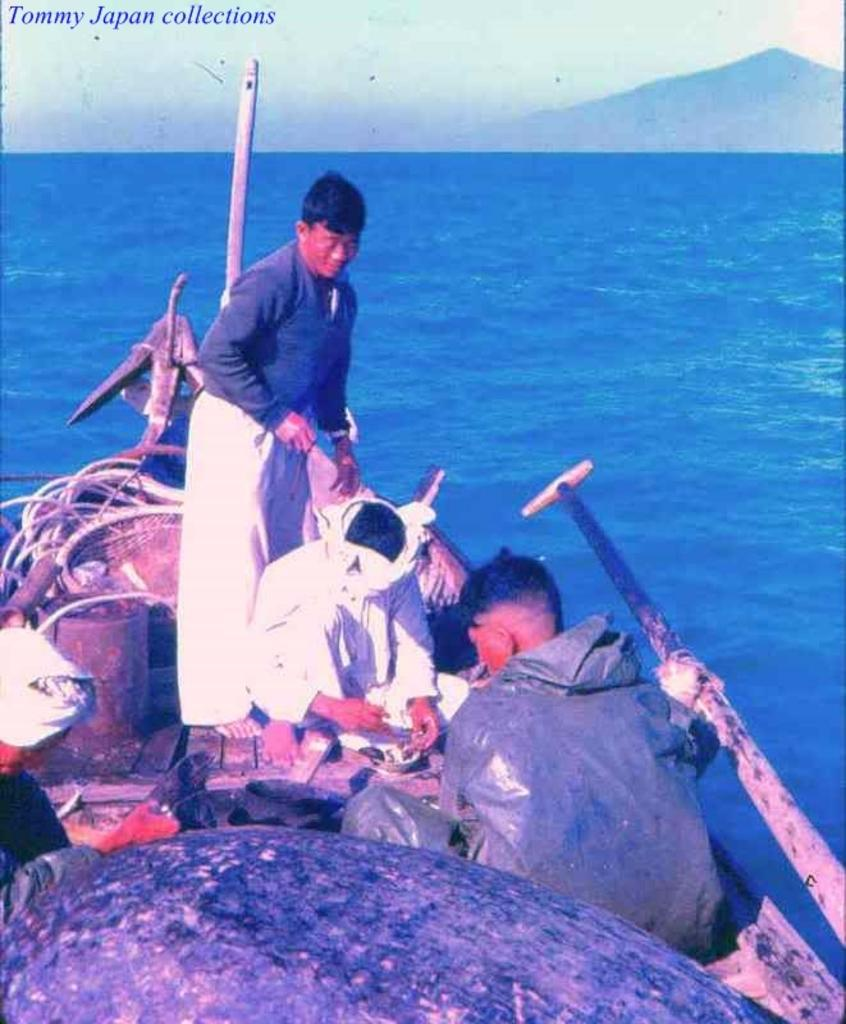What are the people doing in the image? The people are on a boat in the image. Where is the boat located? The boat is on water. What can be seen in the background of the image? There are mountains and the sky visible in the background of the image. What type of bean is being cooked on the boat in the image? There is no bean being cooked on the boat in the image. 